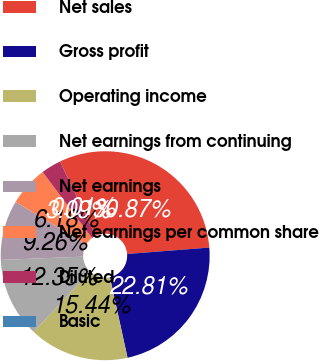Convert chart. <chart><loc_0><loc_0><loc_500><loc_500><pie_chart><fcel>Net sales<fcel>Gross profit<fcel>Operating income<fcel>Net earnings from continuing<fcel>Net earnings<fcel>Net earnings per common share<fcel>Diluted<fcel>Basic<nl><fcel>30.87%<fcel>22.81%<fcel>15.44%<fcel>12.35%<fcel>9.26%<fcel>6.18%<fcel>3.09%<fcel>0.01%<nl></chart> 